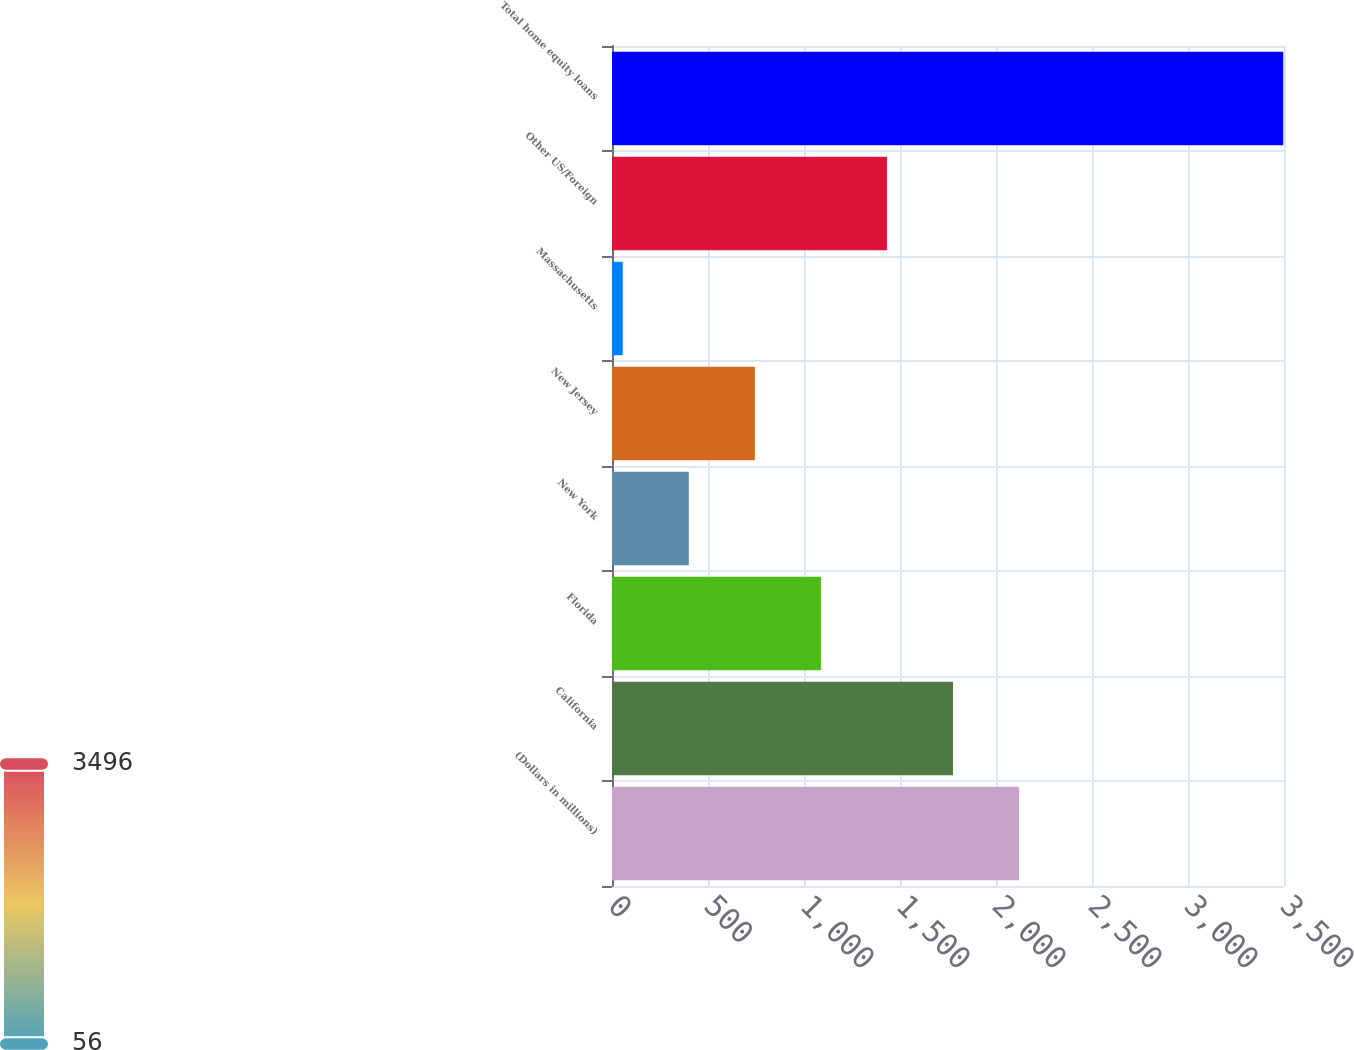Convert chart. <chart><loc_0><loc_0><loc_500><loc_500><bar_chart><fcel>(Dollars in millions)<fcel>California<fcel>Florida<fcel>New York<fcel>New Jersey<fcel>Massachusetts<fcel>Other US/Foreign<fcel>Total home equity loans<nl><fcel>2120<fcel>1776<fcel>1088<fcel>400<fcel>744<fcel>56<fcel>1432<fcel>3496<nl></chart> 